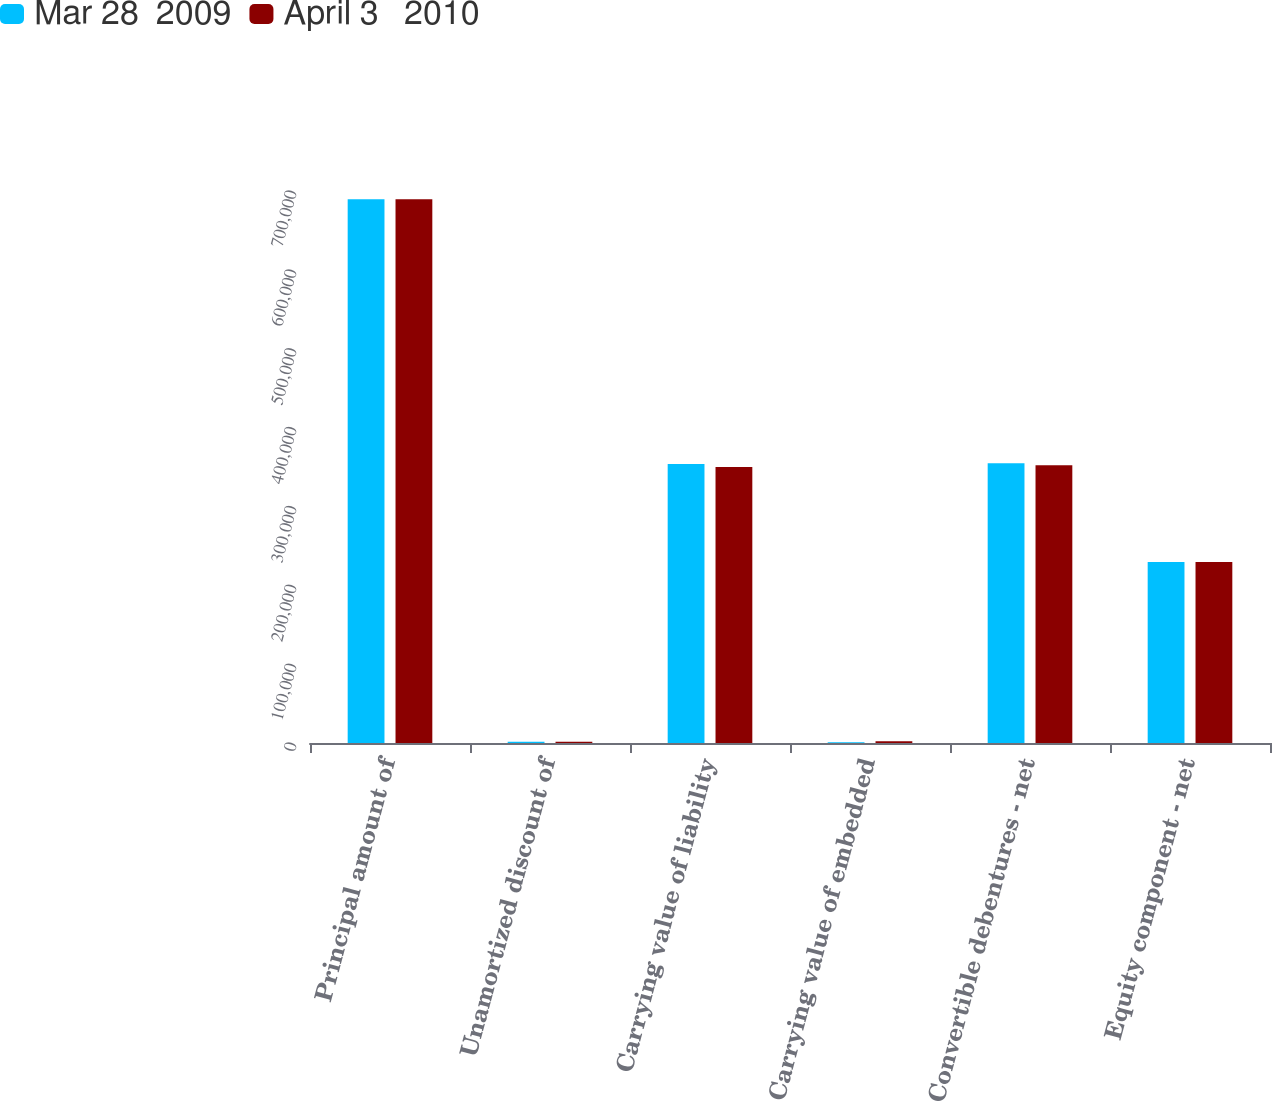<chart> <loc_0><loc_0><loc_500><loc_500><stacked_bar_chart><ecel><fcel>Principal amount of<fcel>Unamortized discount of<fcel>Carrying value of liability<fcel>Carrying value of embedded<fcel>Convertible debentures - net<fcel>Equity component - net<nl><fcel>Mar 28  2009<fcel>689635<fcel>1562<fcel>353950<fcel>848<fcel>354798<fcel>229513<nl><fcel>April 3   2010<fcel>689635<fcel>1620<fcel>350000<fcel>2110<fcel>352110<fcel>229513<nl></chart> 